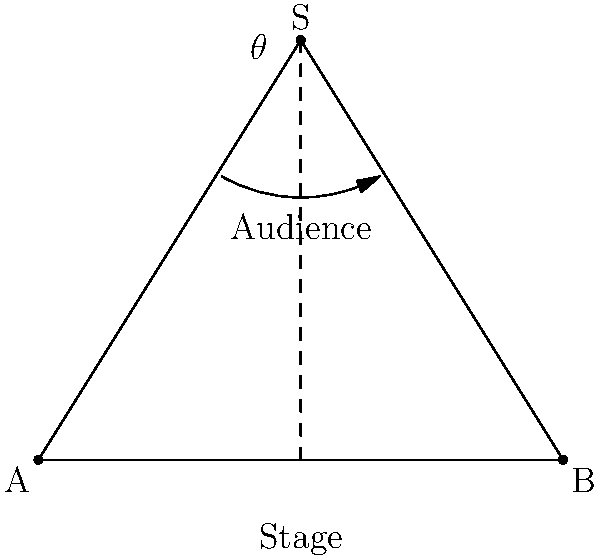As a singer-songwriter planning your next concert, you're designing an innovative triangular stage layout to maximize audience engagement. The stage forms an isosceles triangle with base length 10 meters and height 8 meters. What is the optimal angle $\theta$ (in degrees) at the apex of the stage that ensures the best balance between proximity to the audience and stage width? To find the optimal angle $\theta$ at the apex of the isosceles triangular stage, we'll follow these steps:

1) In an isosceles triangle, the apex angle bisector is perpendicular to the base and divides it into two equal parts. This creates two right triangles.

2) Let's focus on one of these right triangles. We know:
   - Half of the base length: $5$ meters
   - Height of the triangle: $8$ meters

3) We can use the tangent function to find half of the apex angle:
   
   $\tan(\frac{\theta}{2}) = \frac{5}{8}$

4) To solve for $\theta$, we use the inverse tangent (arctangent) function and multiply by 2:

   $\theta = 2 \cdot \arctan(\frac{5}{8})$

5) Calculate:
   $\theta = 2 \cdot \arctan(0.625)$
   $\theta \approx 2 \cdot 32.0053°$
   $\theta \approx 64.0106°$

6) Rounding to the nearest degree:
   $\theta \approx 64°$

This angle provides an optimal balance between stage width and proximity to the audience, allowing for engaging performances while maintaining a connection with the entire crowd.
Answer: 64° 